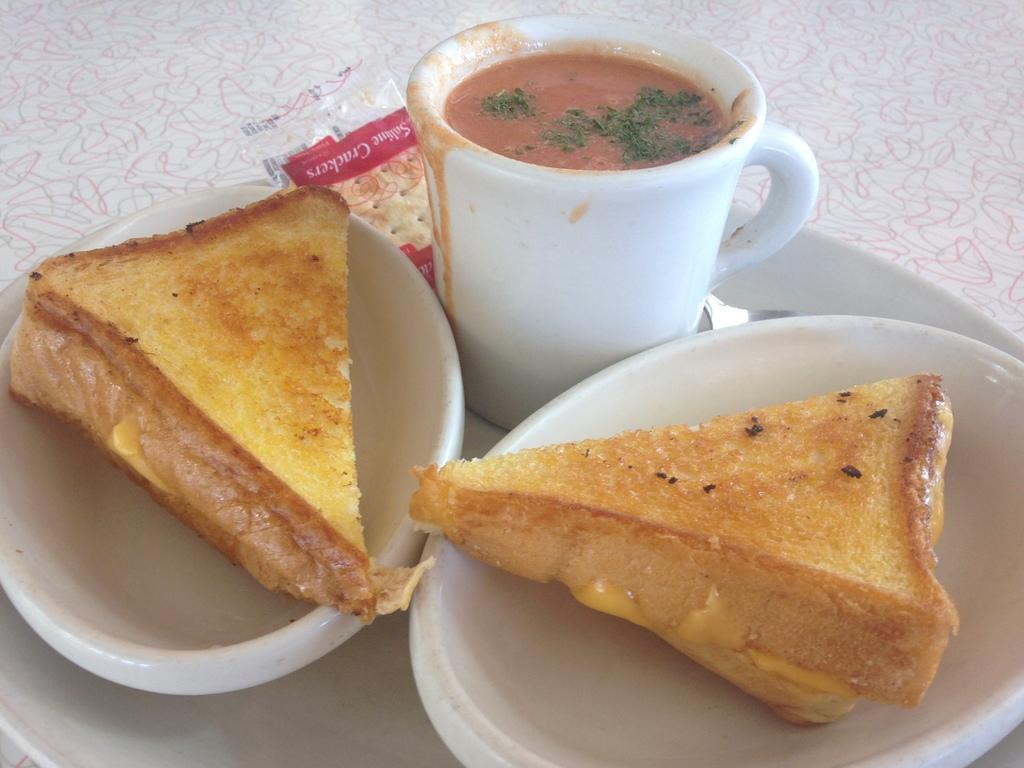What type of food can be seen in the image? There are two slices of sandwich and a cup of soup in the image. What other food items are present in the image? Biscuits are present in the image. How are the biscuits arranged in the image? The biscuits are placed on a plate. What is the plate placed on in the image? The plate is placed on an object. What type of metal is used to make the wine glass in the image? There is no wine glass present in the image. How is the knot tied on the biscuits in the image? The biscuits in the image do not have any knots tied on them. 